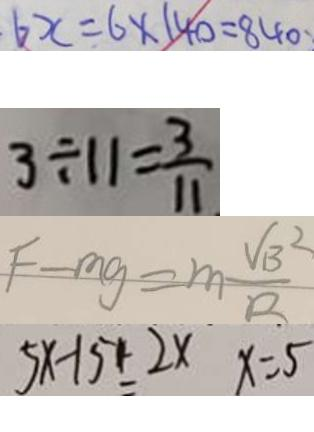Convert formula to latex. <formula><loc_0><loc_0><loc_500><loc_500>6 x = 6 \times 1 4 0 = 8 4 0 
 3 \div 1 1 = \frac { 3 } { 1 1 } 
 F - m g = m \frac { V B ^ { 2 } } { R } 
 5 x - 1 5 - 2 x x = 5</formula> 